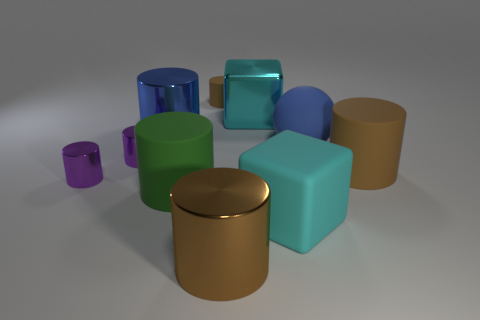There is a blue thing that is the same shape as the big green thing; what is it made of?
Give a very brief answer. Metal. Is the number of cyan things greater than the number of small blocks?
Your response must be concise. Yes. How many other things are there of the same color as the shiny block?
Your response must be concise. 1. Are the large blue sphere and the big blue object that is to the left of the big matte block made of the same material?
Your answer should be very brief. No. There is a cyan block that is in front of the blue thing that is to the left of the matte ball; how many brown cylinders are behind it?
Offer a terse response. 2. Are there fewer purple cylinders in front of the cyan rubber block than brown shiny objects that are in front of the brown shiny cylinder?
Give a very brief answer. No. What number of other objects are the same material as the sphere?
Offer a terse response. 4. What material is the ball that is the same size as the cyan metal block?
Your answer should be compact. Rubber. What number of gray things are large matte objects or big cylinders?
Offer a very short reply. 0. What color is the object that is both behind the blue metallic object and in front of the tiny rubber cylinder?
Provide a short and direct response. Cyan. 